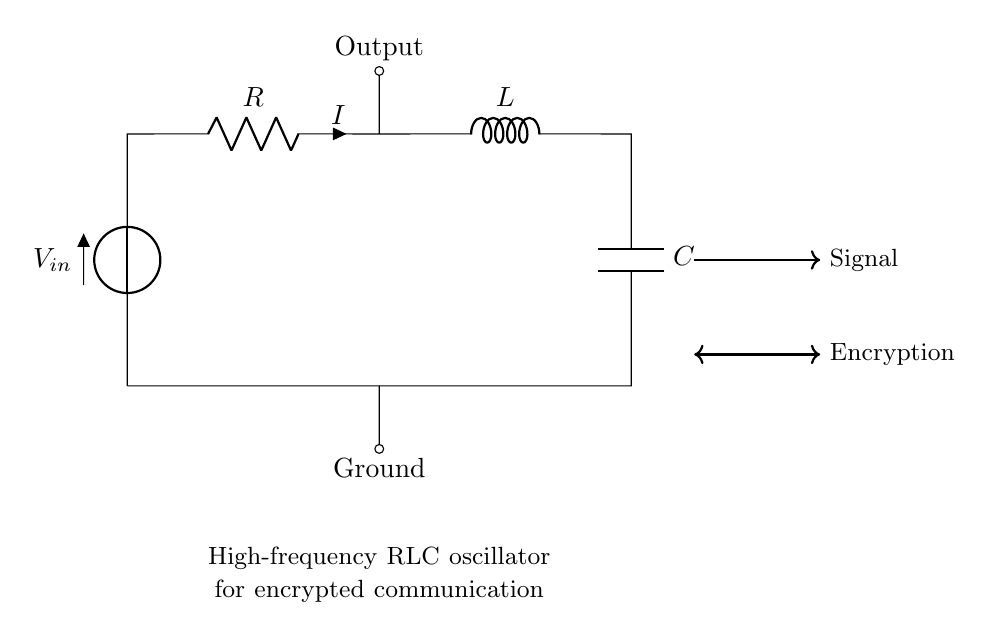What component provides the voltage input in this circuit? The voltage input is provided by the voltage source labeled as V in the circuit diagram.
Answer: V What components are present in this RLC circuit? The components are a resistor (R), an inductor (L), and a capacitor (C), all connected in series, as shown in the circuit.
Answer: Resistor, inductor, capacitor What is the direction of the current in the circuit? The current flows from the positive terminal of the voltage source V into the resistor R, continuing through the inductor L and capacitor C before returning to ground.
Answer: From V to ground What is the purpose of the output shown in the circuit? The output is typically used for taking the oscillating signal generated by the RLC circuit, often for further processing or transmission in communication devices.
Answer: Generate oscillating signal How does the oscillation frequency relate to the values of the components? The oscillation frequency is determined by the values of the resistor, inductor, and capacitor, specifically calculated using the formula for resonant frequency: f = 1/(2π√(LC)). The resistance affects the damping of the oscillation.
Answer: Frequency = 1/(2π√(LC)) What effect does the resistor have in the circuit's operation? The resistor controls the current flow, dissipating energy as heat, and affects the damping of oscillations, which can stabilize the output signal in the oscillating circuit.
Answer: Damping and controlling current flow What role does the capacitor play in the oscillation process? The capacitor stores energy in the electric field and releases it, contributing to the alternating current behavior of the circuit, allowing for sustained oscillations at certain frequencies.
Answer: Stores energy for oscillation 